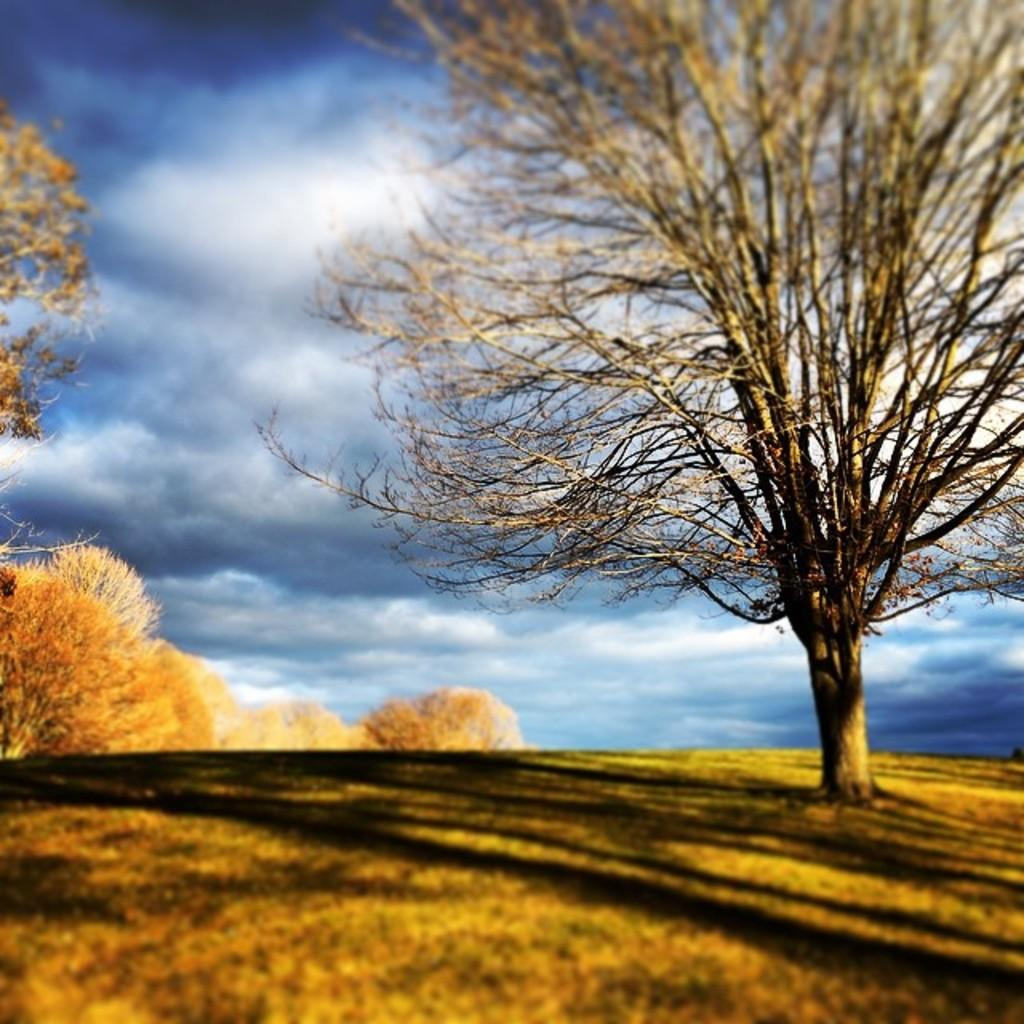What type of vegetation is in the middle of the image? There are trees in the middle of the image. What type of ground cover is at the bottom of the image? There is grass at the bottom of the image. What part of the natural environment is visible at the top of the image? The sky is visible at the top of the image. Can you describe the zephyr blowing through the trees in the image? There is no mention of a zephyr in the image, so we cannot describe it. How does the rainstorm affect the trees in the image? There is no rainstorm present in the image, so we cannot describe its effect on the trees. 